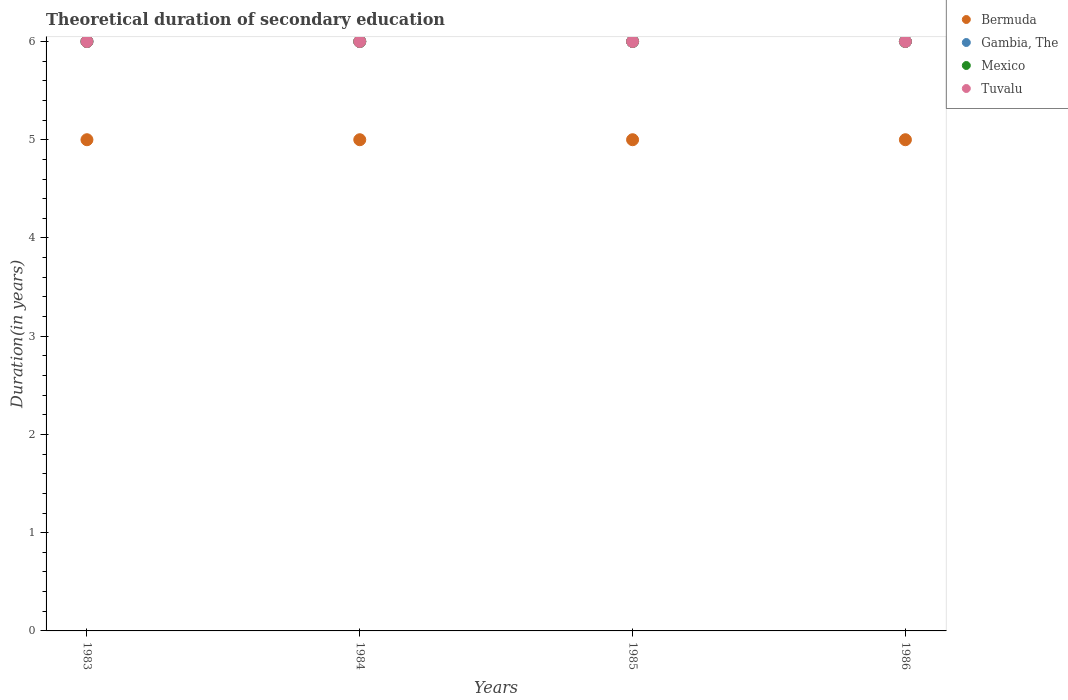How many different coloured dotlines are there?
Give a very brief answer. 4. Across all years, what is the minimum total theoretical duration of secondary education in Tuvalu?
Give a very brief answer. 6. In which year was the total theoretical duration of secondary education in Mexico minimum?
Your answer should be very brief. 1983. What is the total total theoretical duration of secondary education in Tuvalu in the graph?
Ensure brevity in your answer.  24. What is the difference between the total theoretical duration of secondary education in Bermuda in 1984 and that in 1985?
Offer a terse response. 0. What is the difference between the total theoretical duration of secondary education in Bermuda in 1985 and the total theoretical duration of secondary education in Tuvalu in 1983?
Provide a succinct answer. -1. In the year 1986, what is the difference between the total theoretical duration of secondary education in Mexico and total theoretical duration of secondary education in Tuvalu?
Your answer should be very brief. 0. What is the ratio of the total theoretical duration of secondary education in Gambia, The in 1983 to that in 1984?
Make the answer very short. 1. Is it the case that in every year, the sum of the total theoretical duration of secondary education in Bermuda and total theoretical duration of secondary education in Tuvalu  is greater than the sum of total theoretical duration of secondary education in Mexico and total theoretical duration of secondary education in Gambia, The?
Provide a succinct answer. No. Is it the case that in every year, the sum of the total theoretical duration of secondary education in Bermuda and total theoretical duration of secondary education in Gambia, The  is greater than the total theoretical duration of secondary education in Tuvalu?
Your answer should be compact. Yes. Is the total theoretical duration of secondary education in Gambia, The strictly greater than the total theoretical duration of secondary education in Bermuda over the years?
Ensure brevity in your answer.  Yes. How many years are there in the graph?
Offer a terse response. 4. Are the values on the major ticks of Y-axis written in scientific E-notation?
Your answer should be very brief. No. Does the graph contain grids?
Your answer should be very brief. No. How many legend labels are there?
Offer a very short reply. 4. How are the legend labels stacked?
Provide a succinct answer. Vertical. What is the title of the graph?
Your answer should be very brief. Theoretical duration of secondary education. Does "Macao" appear as one of the legend labels in the graph?
Provide a short and direct response. No. What is the label or title of the X-axis?
Offer a very short reply. Years. What is the label or title of the Y-axis?
Give a very brief answer. Duration(in years). What is the Duration(in years) of Gambia, The in 1983?
Give a very brief answer. 6. What is the Duration(in years) in Bermuda in 1984?
Your response must be concise. 5. What is the Duration(in years) of Gambia, The in 1984?
Keep it short and to the point. 6. What is the Duration(in years) in Tuvalu in 1984?
Your response must be concise. 6. What is the Duration(in years) of Bermuda in 1985?
Your response must be concise. 5. What is the Duration(in years) of Gambia, The in 1985?
Give a very brief answer. 6. What is the Duration(in years) of Mexico in 1985?
Your response must be concise. 6. What is the Duration(in years) of Bermuda in 1986?
Your answer should be compact. 5. What is the Duration(in years) of Gambia, The in 1986?
Your answer should be compact. 6. What is the Duration(in years) in Tuvalu in 1986?
Your response must be concise. 6. Across all years, what is the maximum Duration(in years) in Bermuda?
Provide a short and direct response. 5. Across all years, what is the maximum Duration(in years) of Gambia, The?
Keep it short and to the point. 6. Across all years, what is the minimum Duration(in years) of Bermuda?
Your answer should be compact. 5. Across all years, what is the minimum Duration(in years) of Gambia, The?
Your response must be concise. 6. Across all years, what is the minimum Duration(in years) of Mexico?
Your response must be concise. 6. What is the total Duration(in years) of Bermuda in the graph?
Keep it short and to the point. 20. What is the total Duration(in years) of Mexico in the graph?
Offer a very short reply. 24. What is the difference between the Duration(in years) in Gambia, The in 1983 and that in 1984?
Ensure brevity in your answer.  0. What is the difference between the Duration(in years) in Tuvalu in 1983 and that in 1984?
Your answer should be very brief. 0. What is the difference between the Duration(in years) of Bermuda in 1983 and that in 1985?
Provide a succinct answer. 0. What is the difference between the Duration(in years) of Gambia, The in 1983 and that in 1985?
Keep it short and to the point. 0. What is the difference between the Duration(in years) of Mexico in 1983 and that in 1985?
Provide a succinct answer. 0. What is the difference between the Duration(in years) in Tuvalu in 1983 and that in 1986?
Your response must be concise. 0. What is the difference between the Duration(in years) in Bermuda in 1984 and that in 1985?
Your response must be concise. 0. What is the difference between the Duration(in years) in Gambia, The in 1984 and that in 1985?
Your response must be concise. 0. What is the difference between the Duration(in years) in Mexico in 1984 and that in 1985?
Offer a terse response. 0. What is the difference between the Duration(in years) in Gambia, The in 1984 and that in 1986?
Give a very brief answer. 0. What is the difference between the Duration(in years) of Mexico in 1984 and that in 1986?
Give a very brief answer. 0. What is the difference between the Duration(in years) of Tuvalu in 1984 and that in 1986?
Offer a terse response. 0. What is the difference between the Duration(in years) of Bermuda in 1985 and that in 1986?
Make the answer very short. 0. What is the difference between the Duration(in years) in Gambia, The in 1983 and the Duration(in years) in Mexico in 1984?
Give a very brief answer. 0. What is the difference between the Duration(in years) in Bermuda in 1983 and the Duration(in years) in Tuvalu in 1985?
Provide a short and direct response. -1. What is the difference between the Duration(in years) of Gambia, The in 1983 and the Duration(in years) of Tuvalu in 1985?
Ensure brevity in your answer.  0. What is the difference between the Duration(in years) in Bermuda in 1983 and the Duration(in years) in Gambia, The in 1986?
Provide a succinct answer. -1. What is the difference between the Duration(in years) of Bermuda in 1983 and the Duration(in years) of Tuvalu in 1986?
Give a very brief answer. -1. What is the difference between the Duration(in years) of Gambia, The in 1983 and the Duration(in years) of Mexico in 1986?
Your response must be concise. 0. What is the difference between the Duration(in years) of Gambia, The in 1983 and the Duration(in years) of Tuvalu in 1986?
Your answer should be compact. 0. What is the difference between the Duration(in years) of Mexico in 1983 and the Duration(in years) of Tuvalu in 1986?
Keep it short and to the point. 0. What is the difference between the Duration(in years) in Bermuda in 1984 and the Duration(in years) in Gambia, The in 1985?
Your response must be concise. -1. What is the difference between the Duration(in years) of Mexico in 1984 and the Duration(in years) of Tuvalu in 1985?
Your answer should be compact. 0. What is the difference between the Duration(in years) in Bermuda in 1984 and the Duration(in years) in Gambia, The in 1986?
Offer a terse response. -1. What is the difference between the Duration(in years) in Bermuda in 1984 and the Duration(in years) in Tuvalu in 1986?
Your answer should be compact. -1. What is the average Duration(in years) in Bermuda per year?
Your response must be concise. 5. What is the average Duration(in years) in Mexico per year?
Your answer should be compact. 6. In the year 1983, what is the difference between the Duration(in years) of Gambia, The and Duration(in years) of Mexico?
Your answer should be very brief. 0. In the year 1984, what is the difference between the Duration(in years) in Bermuda and Duration(in years) in Mexico?
Offer a very short reply. -1. In the year 1984, what is the difference between the Duration(in years) of Bermuda and Duration(in years) of Tuvalu?
Your response must be concise. -1. In the year 1984, what is the difference between the Duration(in years) of Gambia, The and Duration(in years) of Mexico?
Ensure brevity in your answer.  0. In the year 1985, what is the difference between the Duration(in years) in Bermuda and Duration(in years) in Gambia, The?
Offer a very short reply. -1. In the year 1985, what is the difference between the Duration(in years) of Gambia, The and Duration(in years) of Mexico?
Keep it short and to the point. 0. In the year 1985, what is the difference between the Duration(in years) of Gambia, The and Duration(in years) of Tuvalu?
Offer a very short reply. 0. In the year 1985, what is the difference between the Duration(in years) of Mexico and Duration(in years) of Tuvalu?
Offer a terse response. 0. In the year 1986, what is the difference between the Duration(in years) in Bermuda and Duration(in years) in Tuvalu?
Your answer should be very brief. -1. In the year 1986, what is the difference between the Duration(in years) of Gambia, The and Duration(in years) of Mexico?
Your response must be concise. 0. What is the ratio of the Duration(in years) of Bermuda in 1983 to that in 1984?
Your answer should be compact. 1. What is the ratio of the Duration(in years) of Mexico in 1983 to that in 1984?
Ensure brevity in your answer.  1. What is the ratio of the Duration(in years) of Bermuda in 1983 to that in 1985?
Offer a terse response. 1. What is the ratio of the Duration(in years) of Gambia, The in 1983 to that in 1985?
Give a very brief answer. 1. What is the ratio of the Duration(in years) in Tuvalu in 1983 to that in 1985?
Your response must be concise. 1. What is the ratio of the Duration(in years) in Mexico in 1983 to that in 1986?
Provide a short and direct response. 1. What is the ratio of the Duration(in years) of Bermuda in 1984 to that in 1985?
Keep it short and to the point. 1. What is the ratio of the Duration(in years) of Gambia, The in 1984 to that in 1985?
Offer a very short reply. 1. What is the ratio of the Duration(in years) of Mexico in 1984 to that in 1985?
Provide a short and direct response. 1. What is the ratio of the Duration(in years) in Bermuda in 1984 to that in 1986?
Offer a terse response. 1. What is the ratio of the Duration(in years) in Gambia, The in 1984 to that in 1986?
Provide a succinct answer. 1. What is the ratio of the Duration(in years) in Mexico in 1984 to that in 1986?
Ensure brevity in your answer.  1. What is the ratio of the Duration(in years) of Tuvalu in 1984 to that in 1986?
Provide a succinct answer. 1. What is the ratio of the Duration(in years) in Bermuda in 1985 to that in 1986?
Provide a short and direct response. 1. What is the ratio of the Duration(in years) of Gambia, The in 1985 to that in 1986?
Your answer should be very brief. 1. What is the difference between the highest and the second highest Duration(in years) in Mexico?
Make the answer very short. 0. What is the difference between the highest and the second highest Duration(in years) of Tuvalu?
Offer a very short reply. 0. What is the difference between the highest and the lowest Duration(in years) of Gambia, The?
Your answer should be compact. 0. What is the difference between the highest and the lowest Duration(in years) in Tuvalu?
Your answer should be compact. 0. 